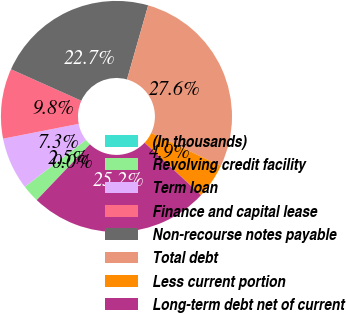<chart> <loc_0><loc_0><loc_500><loc_500><pie_chart><fcel>(In thousands)<fcel>Revolving credit facility<fcel>Term loan<fcel>Finance and capital lease<fcel>Non-recourse notes payable<fcel>Total debt<fcel>Less current portion<fcel>Long-term debt net of current<nl><fcel>0.01%<fcel>2.45%<fcel>7.34%<fcel>9.78%<fcel>22.73%<fcel>27.62%<fcel>4.89%<fcel>25.18%<nl></chart> 